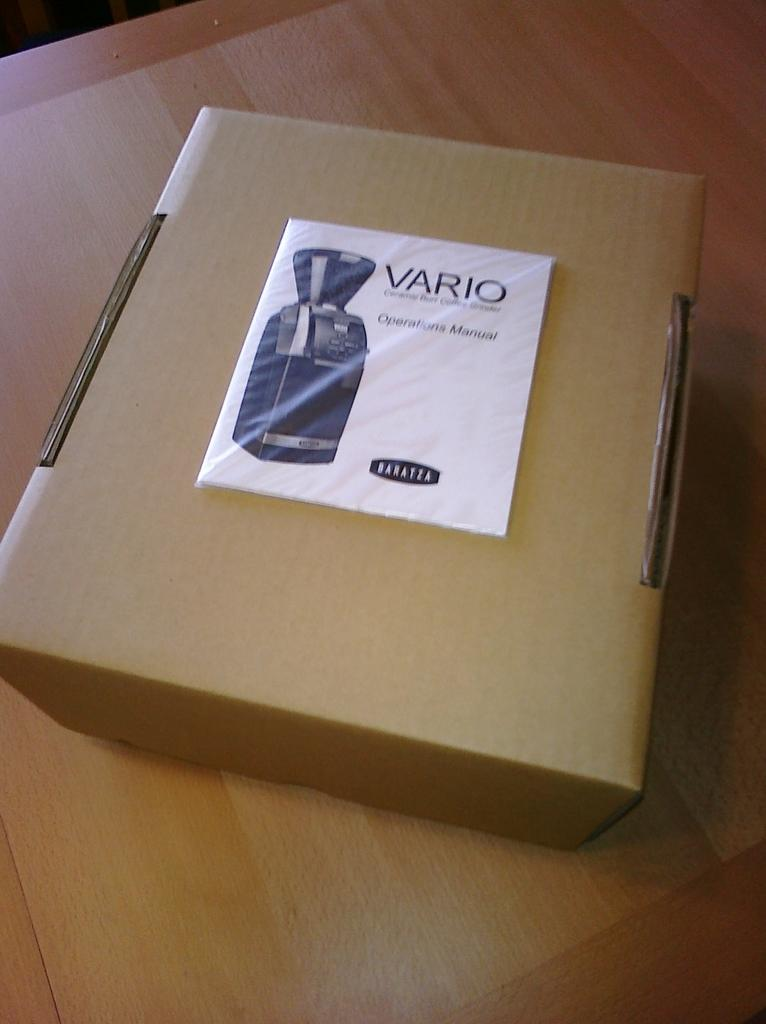<image>
Give a short and clear explanation of the subsequent image. A brown cardboard box with a Vario coffee grinder operations manual on it. 